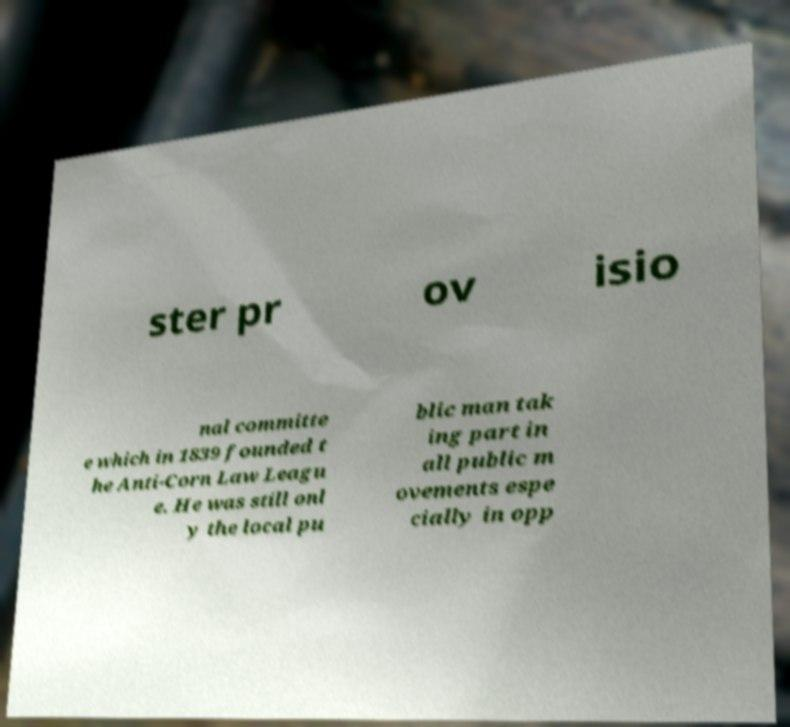I need the written content from this picture converted into text. Can you do that? ster pr ov isio nal committe e which in 1839 founded t he Anti-Corn Law Leagu e. He was still onl y the local pu blic man tak ing part in all public m ovements espe cially in opp 